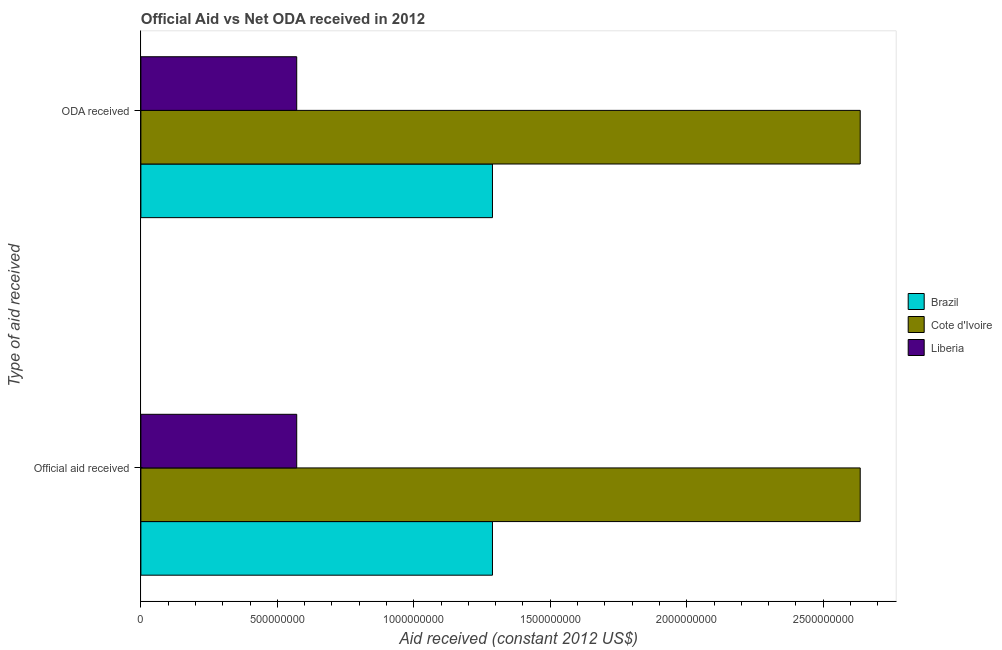How many groups of bars are there?
Make the answer very short. 2. Are the number of bars per tick equal to the number of legend labels?
Make the answer very short. Yes. How many bars are there on the 2nd tick from the top?
Your response must be concise. 3. How many bars are there on the 1st tick from the bottom?
Offer a terse response. 3. What is the label of the 2nd group of bars from the top?
Offer a very short reply. Official aid received. What is the oda received in Brazil?
Your answer should be very brief. 1.29e+09. Across all countries, what is the maximum oda received?
Give a very brief answer. 2.64e+09. Across all countries, what is the minimum oda received?
Offer a very short reply. 5.71e+08. In which country was the oda received maximum?
Your answer should be compact. Cote d'Ivoire. In which country was the oda received minimum?
Provide a short and direct response. Liberia. What is the total oda received in the graph?
Provide a short and direct response. 4.49e+09. What is the difference between the oda received in Brazil and that in Liberia?
Your response must be concise. 7.17e+08. What is the difference between the oda received in Liberia and the official aid received in Brazil?
Provide a short and direct response. -7.17e+08. What is the average official aid received per country?
Provide a succinct answer. 1.50e+09. What is the difference between the official aid received and oda received in Liberia?
Your answer should be very brief. 0. What is the ratio of the official aid received in Brazil to that in Cote d'Ivoire?
Provide a short and direct response. 0.49. Is the oda received in Liberia less than that in Cote d'Ivoire?
Provide a short and direct response. Yes. In how many countries, is the oda received greater than the average oda received taken over all countries?
Offer a very short reply. 1. What does the 1st bar from the top in ODA received represents?
Ensure brevity in your answer.  Liberia. What does the 2nd bar from the bottom in Official aid received represents?
Make the answer very short. Cote d'Ivoire. What is the difference between two consecutive major ticks on the X-axis?
Offer a very short reply. 5.00e+08. Does the graph contain grids?
Give a very brief answer. No. Where does the legend appear in the graph?
Your answer should be very brief. Center right. What is the title of the graph?
Your answer should be very brief. Official Aid vs Net ODA received in 2012 . Does "Small states" appear as one of the legend labels in the graph?
Your answer should be compact. No. What is the label or title of the X-axis?
Give a very brief answer. Aid received (constant 2012 US$). What is the label or title of the Y-axis?
Make the answer very short. Type of aid received. What is the Aid received (constant 2012 US$) in Brazil in Official aid received?
Ensure brevity in your answer.  1.29e+09. What is the Aid received (constant 2012 US$) of Cote d'Ivoire in Official aid received?
Give a very brief answer. 2.64e+09. What is the Aid received (constant 2012 US$) of Liberia in Official aid received?
Keep it short and to the point. 5.71e+08. What is the Aid received (constant 2012 US$) of Brazil in ODA received?
Offer a terse response. 1.29e+09. What is the Aid received (constant 2012 US$) of Cote d'Ivoire in ODA received?
Your answer should be very brief. 2.64e+09. What is the Aid received (constant 2012 US$) in Liberia in ODA received?
Ensure brevity in your answer.  5.71e+08. Across all Type of aid received, what is the maximum Aid received (constant 2012 US$) in Brazil?
Your response must be concise. 1.29e+09. Across all Type of aid received, what is the maximum Aid received (constant 2012 US$) of Cote d'Ivoire?
Offer a terse response. 2.64e+09. Across all Type of aid received, what is the maximum Aid received (constant 2012 US$) in Liberia?
Your answer should be compact. 5.71e+08. Across all Type of aid received, what is the minimum Aid received (constant 2012 US$) of Brazil?
Give a very brief answer. 1.29e+09. Across all Type of aid received, what is the minimum Aid received (constant 2012 US$) of Cote d'Ivoire?
Provide a succinct answer. 2.64e+09. Across all Type of aid received, what is the minimum Aid received (constant 2012 US$) in Liberia?
Give a very brief answer. 5.71e+08. What is the total Aid received (constant 2012 US$) of Brazil in the graph?
Your response must be concise. 2.58e+09. What is the total Aid received (constant 2012 US$) of Cote d'Ivoire in the graph?
Give a very brief answer. 5.27e+09. What is the total Aid received (constant 2012 US$) in Liberia in the graph?
Make the answer very short. 1.14e+09. What is the difference between the Aid received (constant 2012 US$) of Liberia in Official aid received and that in ODA received?
Provide a succinct answer. 0. What is the difference between the Aid received (constant 2012 US$) in Brazil in Official aid received and the Aid received (constant 2012 US$) in Cote d'Ivoire in ODA received?
Provide a short and direct response. -1.35e+09. What is the difference between the Aid received (constant 2012 US$) in Brazil in Official aid received and the Aid received (constant 2012 US$) in Liberia in ODA received?
Provide a short and direct response. 7.17e+08. What is the difference between the Aid received (constant 2012 US$) in Cote d'Ivoire in Official aid received and the Aid received (constant 2012 US$) in Liberia in ODA received?
Your answer should be compact. 2.06e+09. What is the average Aid received (constant 2012 US$) in Brazil per Type of aid received?
Offer a very short reply. 1.29e+09. What is the average Aid received (constant 2012 US$) in Cote d'Ivoire per Type of aid received?
Your answer should be very brief. 2.64e+09. What is the average Aid received (constant 2012 US$) in Liberia per Type of aid received?
Offer a terse response. 5.71e+08. What is the difference between the Aid received (constant 2012 US$) in Brazil and Aid received (constant 2012 US$) in Cote d'Ivoire in Official aid received?
Provide a succinct answer. -1.35e+09. What is the difference between the Aid received (constant 2012 US$) in Brazil and Aid received (constant 2012 US$) in Liberia in Official aid received?
Your response must be concise. 7.17e+08. What is the difference between the Aid received (constant 2012 US$) in Cote d'Ivoire and Aid received (constant 2012 US$) in Liberia in Official aid received?
Offer a very short reply. 2.06e+09. What is the difference between the Aid received (constant 2012 US$) in Brazil and Aid received (constant 2012 US$) in Cote d'Ivoire in ODA received?
Your response must be concise. -1.35e+09. What is the difference between the Aid received (constant 2012 US$) of Brazil and Aid received (constant 2012 US$) of Liberia in ODA received?
Keep it short and to the point. 7.17e+08. What is the difference between the Aid received (constant 2012 US$) of Cote d'Ivoire and Aid received (constant 2012 US$) of Liberia in ODA received?
Provide a succinct answer. 2.06e+09. What is the difference between the highest and the second highest Aid received (constant 2012 US$) in Liberia?
Offer a very short reply. 0. What is the difference between the highest and the lowest Aid received (constant 2012 US$) in Brazil?
Offer a terse response. 0. What is the difference between the highest and the lowest Aid received (constant 2012 US$) in Cote d'Ivoire?
Offer a terse response. 0. What is the difference between the highest and the lowest Aid received (constant 2012 US$) in Liberia?
Ensure brevity in your answer.  0. 